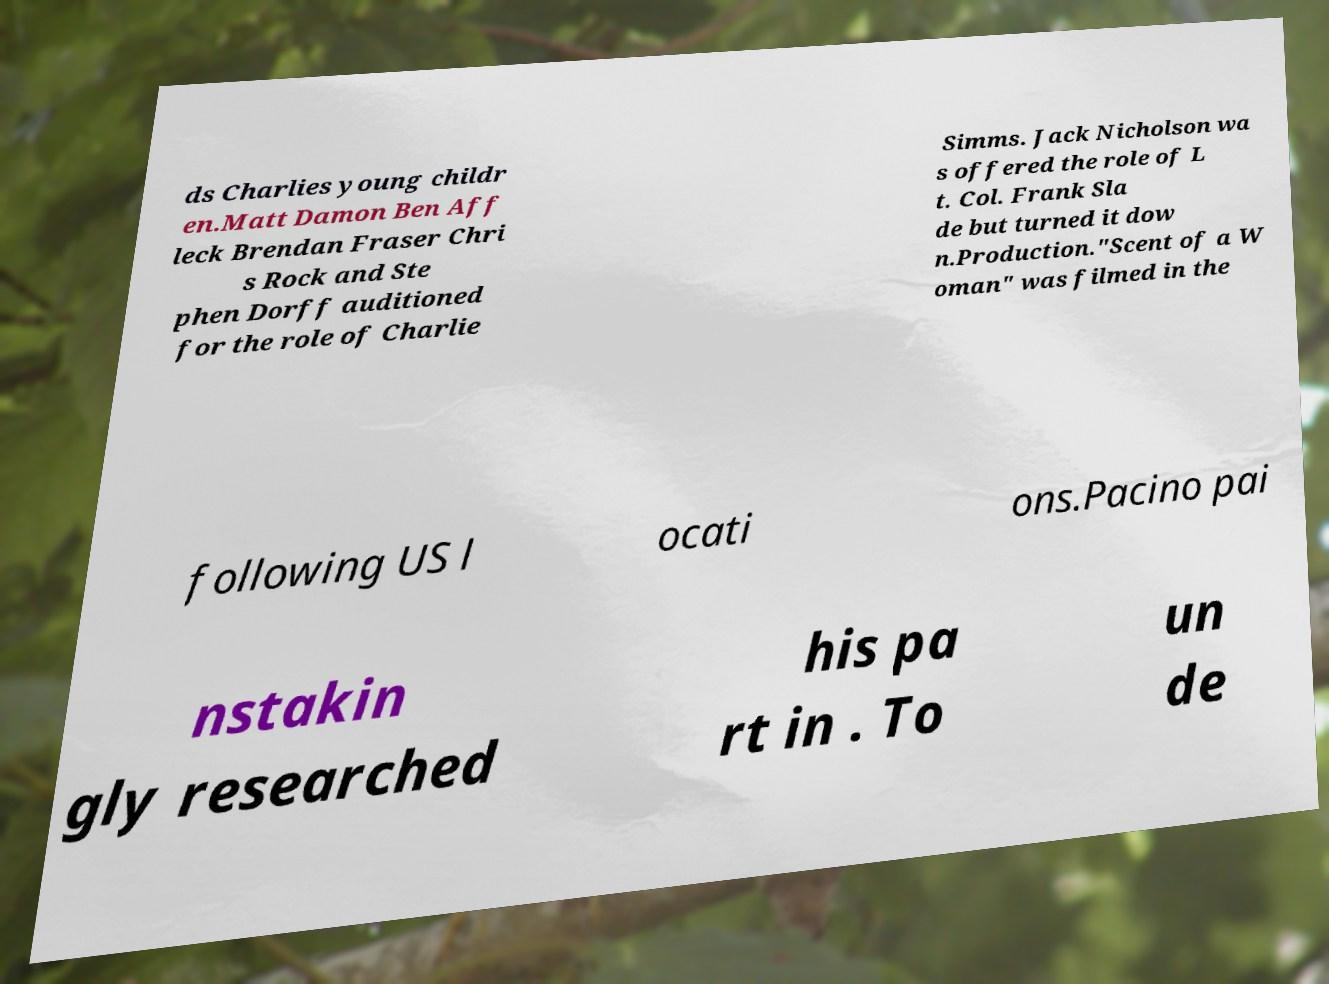For documentation purposes, I need the text within this image transcribed. Could you provide that? ds Charlies young childr en.Matt Damon Ben Aff leck Brendan Fraser Chri s Rock and Ste phen Dorff auditioned for the role of Charlie Simms. Jack Nicholson wa s offered the role of L t. Col. Frank Sla de but turned it dow n.Production."Scent of a W oman" was filmed in the following US l ocati ons.Pacino pai nstakin gly researched his pa rt in . To un de 